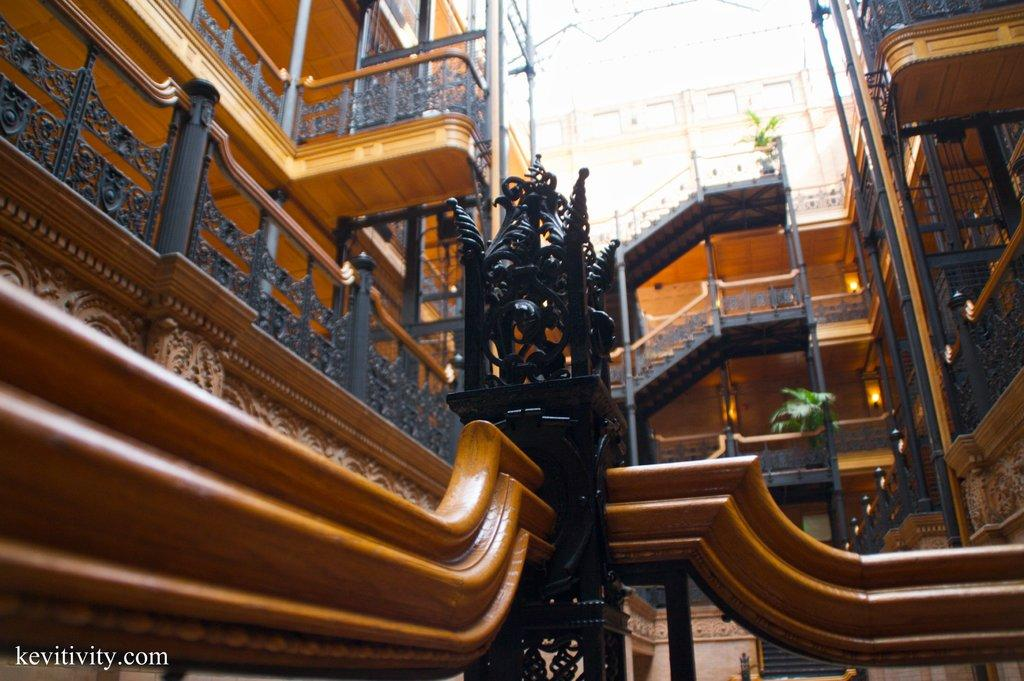What type of structure is visible in the image? There is a building in the image. What architectural feature is located in the middle of the building? There is a staircase in the middle of the building. What safety feature is present at the bottom of the staircase? There is a railing at the bottom of the staircase. What type of lighting is attached to the building? Lamps are attached to the building. What type of sea creatures can be seen swimming near the building in the image? There is no sea or sea creatures present in the image; it features a building with a staircase, railing, and lamps. 